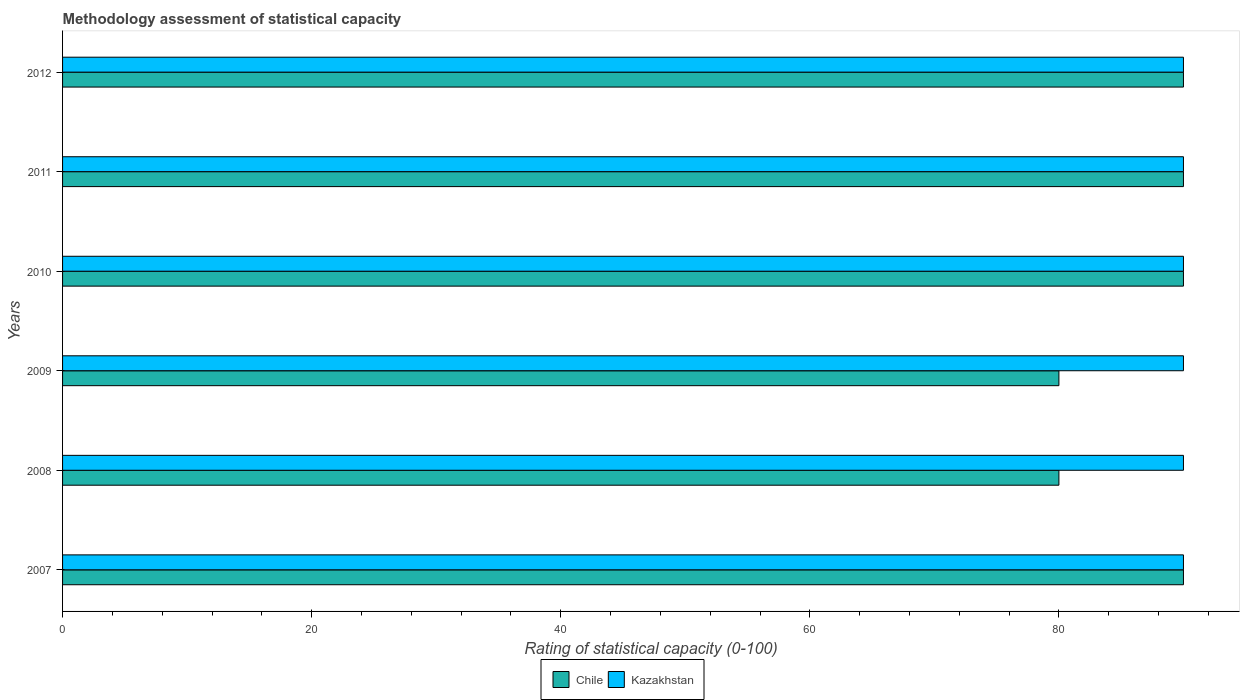How many groups of bars are there?
Your response must be concise. 6. Are the number of bars on each tick of the Y-axis equal?
Provide a short and direct response. Yes. How many bars are there on the 5th tick from the top?
Make the answer very short. 2. What is the label of the 5th group of bars from the top?
Provide a succinct answer. 2008. What is the rating of statistical capacity in Kazakhstan in 2012?
Make the answer very short. 90. Across all years, what is the maximum rating of statistical capacity in Kazakhstan?
Offer a terse response. 90. Across all years, what is the minimum rating of statistical capacity in Chile?
Offer a very short reply. 80. In which year was the rating of statistical capacity in Chile maximum?
Give a very brief answer. 2007. In which year was the rating of statistical capacity in Chile minimum?
Your response must be concise. 2008. What is the total rating of statistical capacity in Kazakhstan in the graph?
Make the answer very short. 540. What is the difference between the rating of statistical capacity in Kazakhstan in 2008 and that in 2011?
Offer a very short reply. 0. What is the difference between the rating of statistical capacity in Kazakhstan in 2010 and the rating of statistical capacity in Chile in 2007?
Your response must be concise. 0. What is the average rating of statistical capacity in Chile per year?
Your answer should be compact. 86.67. In the year 2009, what is the difference between the rating of statistical capacity in Chile and rating of statistical capacity in Kazakhstan?
Make the answer very short. -10. Is the difference between the rating of statistical capacity in Chile in 2011 and 2012 greater than the difference between the rating of statistical capacity in Kazakhstan in 2011 and 2012?
Your response must be concise. No. What is the difference between the highest and the lowest rating of statistical capacity in Chile?
Offer a very short reply. 10. In how many years, is the rating of statistical capacity in Chile greater than the average rating of statistical capacity in Chile taken over all years?
Your answer should be very brief. 4. What does the 1st bar from the top in 2009 represents?
Provide a succinct answer. Kazakhstan. Are all the bars in the graph horizontal?
Ensure brevity in your answer.  Yes. Does the graph contain any zero values?
Offer a terse response. No. What is the title of the graph?
Provide a short and direct response. Methodology assessment of statistical capacity. What is the label or title of the X-axis?
Make the answer very short. Rating of statistical capacity (0-100). What is the label or title of the Y-axis?
Your response must be concise. Years. What is the Rating of statistical capacity (0-100) of Kazakhstan in 2007?
Your answer should be very brief. 90. What is the Rating of statistical capacity (0-100) in Chile in 2008?
Provide a succinct answer. 80. What is the Rating of statistical capacity (0-100) of Kazakhstan in 2008?
Your answer should be compact. 90. What is the Rating of statistical capacity (0-100) in Kazakhstan in 2011?
Provide a succinct answer. 90. What is the Rating of statistical capacity (0-100) in Chile in 2012?
Offer a very short reply. 90. What is the Rating of statistical capacity (0-100) in Kazakhstan in 2012?
Offer a very short reply. 90. Across all years, what is the maximum Rating of statistical capacity (0-100) in Chile?
Keep it short and to the point. 90. Across all years, what is the maximum Rating of statistical capacity (0-100) of Kazakhstan?
Ensure brevity in your answer.  90. What is the total Rating of statistical capacity (0-100) of Chile in the graph?
Offer a very short reply. 520. What is the total Rating of statistical capacity (0-100) in Kazakhstan in the graph?
Make the answer very short. 540. What is the difference between the Rating of statistical capacity (0-100) of Kazakhstan in 2007 and that in 2008?
Your answer should be very brief. 0. What is the difference between the Rating of statistical capacity (0-100) of Chile in 2007 and that in 2010?
Offer a very short reply. 0. What is the difference between the Rating of statistical capacity (0-100) of Kazakhstan in 2007 and that in 2010?
Ensure brevity in your answer.  0. What is the difference between the Rating of statistical capacity (0-100) in Chile in 2007 and that in 2011?
Keep it short and to the point. 0. What is the difference between the Rating of statistical capacity (0-100) in Chile in 2007 and that in 2012?
Offer a terse response. 0. What is the difference between the Rating of statistical capacity (0-100) of Kazakhstan in 2008 and that in 2010?
Keep it short and to the point. 0. What is the difference between the Rating of statistical capacity (0-100) of Chile in 2008 and that in 2011?
Your response must be concise. -10. What is the difference between the Rating of statistical capacity (0-100) of Kazakhstan in 2008 and that in 2011?
Provide a short and direct response. 0. What is the difference between the Rating of statistical capacity (0-100) in Kazakhstan in 2008 and that in 2012?
Keep it short and to the point. 0. What is the difference between the Rating of statistical capacity (0-100) of Chile in 2009 and that in 2010?
Offer a terse response. -10. What is the difference between the Rating of statistical capacity (0-100) of Chile in 2009 and that in 2012?
Your answer should be very brief. -10. What is the difference between the Rating of statistical capacity (0-100) in Chile in 2010 and that in 2012?
Your answer should be very brief. 0. What is the difference between the Rating of statistical capacity (0-100) of Kazakhstan in 2010 and that in 2012?
Offer a very short reply. 0. What is the difference between the Rating of statistical capacity (0-100) of Chile in 2011 and that in 2012?
Give a very brief answer. 0. What is the difference between the Rating of statistical capacity (0-100) in Chile in 2007 and the Rating of statistical capacity (0-100) in Kazakhstan in 2008?
Give a very brief answer. 0. What is the difference between the Rating of statistical capacity (0-100) in Chile in 2007 and the Rating of statistical capacity (0-100) in Kazakhstan in 2009?
Your answer should be compact. 0. What is the difference between the Rating of statistical capacity (0-100) in Chile in 2007 and the Rating of statistical capacity (0-100) in Kazakhstan in 2010?
Ensure brevity in your answer.  0. What is the difference between the Rating of statistical capacity (0-100) in Chile in 2008 and the Rating of statistical capacity (0-100) in Kazakhstan in 2009?
Your response must be concise. -10. What is the difference between the Rating of statistical capacity (0-100) of Chile in 2008 and the Rating of statistical capacity (0-100) of Kazakhstan in 2012?
Offer a very short reply. -10. What is the difference between the Rating of statistical capacity (0-100) of Chile in 2009 and the Rating of statistical capacity (0-100) of Kazakhstan in 2011?
Your answer should be very brief. -10. What is the difference between the Rating of statistical capacity (0-100) of Chile in 2009 and the Rating of statistical capacity (0-100) of Kazakhstan in 2012?
Make the answer very short. -10. What is the difference between the Rating of statistical capacity (0-100) of Chile in 2011 and the Rating of statistical capacity (0-100) of Kazakhstan in 2012?
Your answer should be very brief. 0. What is the average Rating of statistical capacity (0-100) of Chile per year?
Provide a short and direct response. 86.67. In the year 2009, what is the difference between the Rating of statistical capacity (0-100) of Chile and Rating of statistical capacity (0-100) of Kazakhstan?
Provide a succinct answer. -10. In the year 2011, what is the difference between the Rating of statistical capacity (0-100) in Chile and Rating of statistical capacity (0-100) in Kazakhstan?
Offer a terse response. 0. In the year 2012, what is the difference between the Rating of statistical capacity (0-100) of Chile and Rating of statistical capacity (0-100) of Kazakhstan?
Give a very brief answer. 0. What is the ratio of the Rating of statistical capacity (0-100) in Kazakhstan in 2007 to that in 2009?
Offer a very short reply. 1. What is the ratio of the Rating of statistical capacity (0-100) of Kazakhstan in 2007 to that in 2010?
Give a very brief answer. 1. What is the ratio of the Rating of statistical capacity (0-100) in Chile in 2007 to that in 2011?
Make the answer very short. 1. What is the ratio of the Rating of statistical capacity (0-100) in Kazakhstan in 2007 to that in 2011?
Give a very brief answer. 1. What is the ratio of the Rating of statistical capacity (0-100) in Chile in 2007 to that in 2012?
Keep it short and to the point. 1. What is the ratio of the Rating of statistical capacity (0-100) in Chile in 2008 to that in 2009?
Keep it short and to the point. 1. What is the ratio of the Rating of statistical capacity (0-100) of Chile in 2008 to that in 2010?
Ensure brevity in your answer.  0.89. What is the ratio of the Rating of statistical capacity (0-100) in Kazakhstan in 2008 to that in 2010?
Provide a succinct answer. 1. What is the ratio of the Rating of statistical capacity (0-100) in Kazakhstan in 2009 to that in 2010?
Offer a very short reply. 1. What is the ratio of the Rating of statistical capacity (0-100) in Kazakhstan in 2009 to that in 2011?
Keep it short and to the point. 1. What is the ratio of the Rating of statistical capacity (0-100) in Kazakhstan in 2010 to that in 2011?
Offer a terse response. 1. What is the ratio of the Rating of statistical capacity (0-100) of Chile in 2010 to that in 2012?
Give a very brief answer. 1. What is the ratio of the Rating of statistical capacity (0-100) of Kazakhstan in 2010 to that in 2012?
Offer a terse response. 1. What is the ratio of the Rating of statistical capacity (0-100) of Chile in 2011 to that in 2012?
Provide a succinct answer. 1. What is the ratio of the Rating of statistical capacity (0-100) in Kazakhstan in 2011 to that in 2012?
Offer a very short reply. 1. What is the difference between the highest and the second highest Rating of statistical capacity (0-100) of Chile?
Your answer should be very brief. 0. What is the difference between the highest and the second highest Rating of statistical capacity (0-100) of Kazakhstan?
Make the answer very short. 0. What is the difference between the highest and the lowest Rating of statistical capacity (0-100) of Chile?
Make the answer very short. 10. What is the difference between the highest and the lowest Rating of statistical capacity (0-100) in Kazakhstan?
Offer a very short reply. 0. 